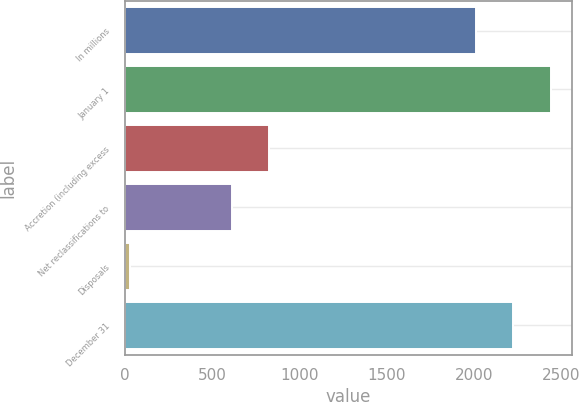<chart> <loc_0><loc_0><loc_500><loc_500><bar_chart><fcel>In millions<fcel>January 1<fcel>Accretion (including excess<fcel>Net reclassifications to<fcel>Disposals<fcel>December 31<nl><fcel>2013<fcel>2440.4<fcel>826.7<fcel>613<fcel>29<fcel>2226.7<nl></chart> 